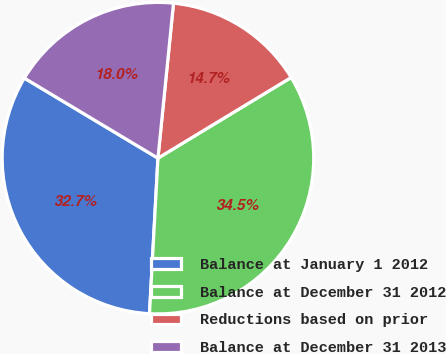Convert chart. <chart><loc_0><loc_0><loc_500><loc_500><pie_chart><fcel>Balance at January 1 2012<fcel>Balance at December 31 2012<fcel>Reductions based on prior<fcel>Balance at December 31 2013<nl><fcel>32.73%<fcel>34.53%<fcel>14.74%<fcel>18.0%<nl></chart> 